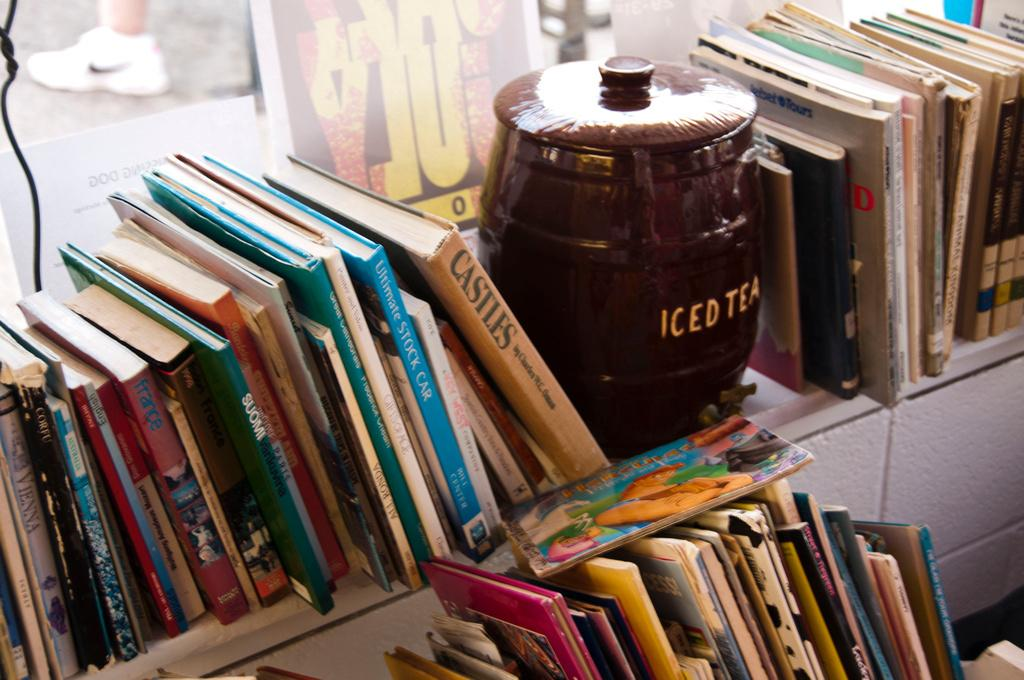<image>
Present a compact description of the photo's key features. A shelf of books with an iced tea barrel 